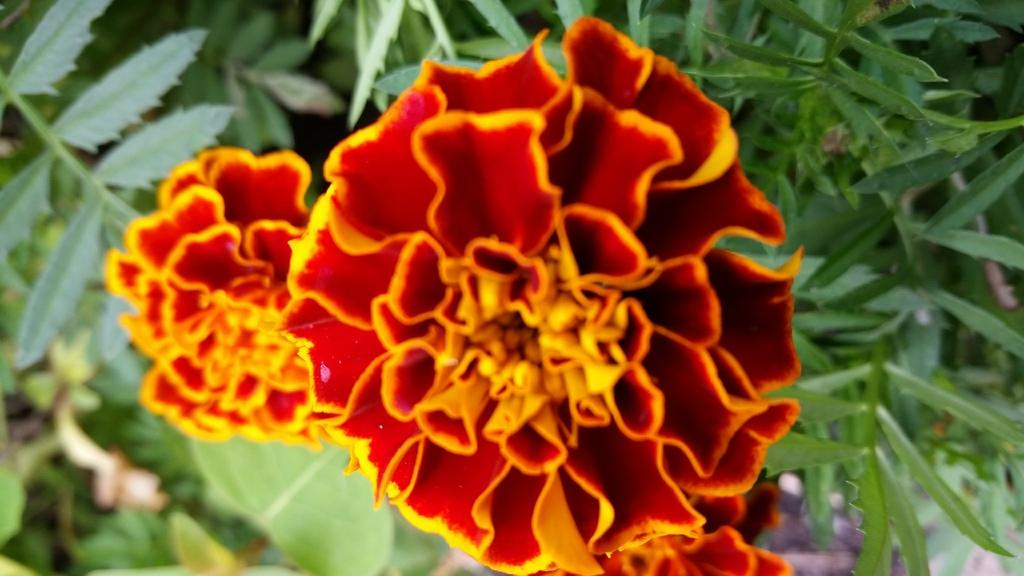What type of living organism is in the picture? There is a plant in the picture. What part of the plant is mentioned in the facts? The plant has a leaf and two flowers. What colors are the petals of the flowers? One flower has a red petal, and the other flower has a yellow petal. What is the aftermath of the landslide in the image? There is no mention of a landslide or any aftermath in the image; it features a plant with two flowers. How many flowers are on the slope in the image? There is no slope or any indication of a slope in the image; it features a plant with two flowers. 